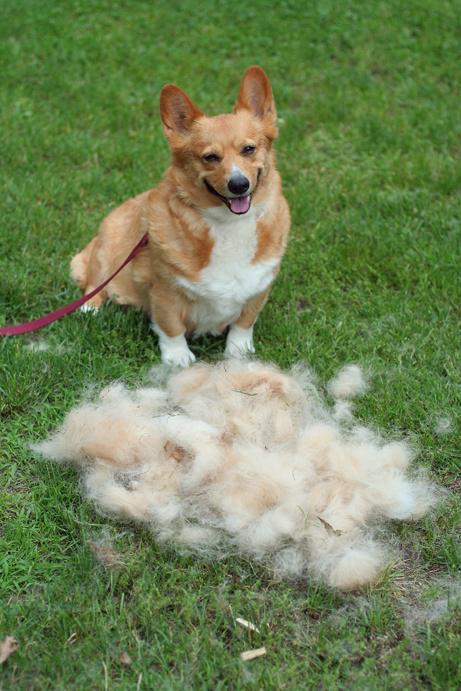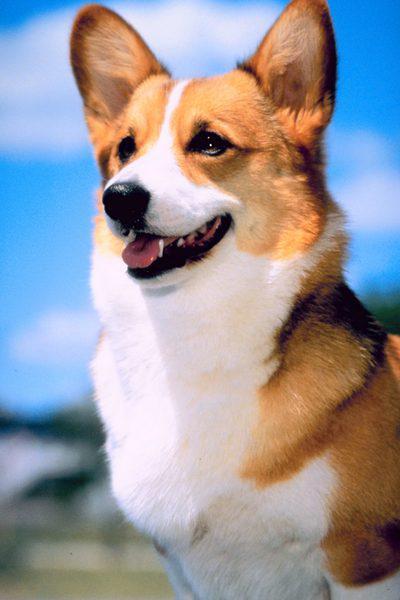The first image is the image on the left, the second image is the image on the right. Considering the images on both sides, is "The dog in the image on the right has its mouth open." valid? Answer yes or no. Yes. The first image is the image on the left, the second image is the image on the right. Examine the images to the left and right. Is the description "The left image shows a corgi sitting on green grass behind a mound of pale dog fir." accurate? Answer yes or no. Yes. 